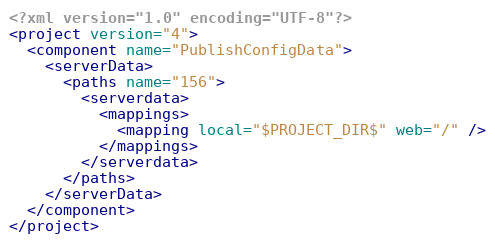<code> <loc_0><loc_0><loc_500><loc_500><_XML_><?xml version="1.0" encoding="UTF-8"?>
<project version="4">
  <component name="PublishConfigData">
    <serverData>
      <paths name="156">
        <serverdata>
          <mappings>
            <mapping local="$PROJECT_DIR$" web="/" />
          </mappings>
        </serverdata>
      </paths>
    </serverData>
  </component>
</project></code> 